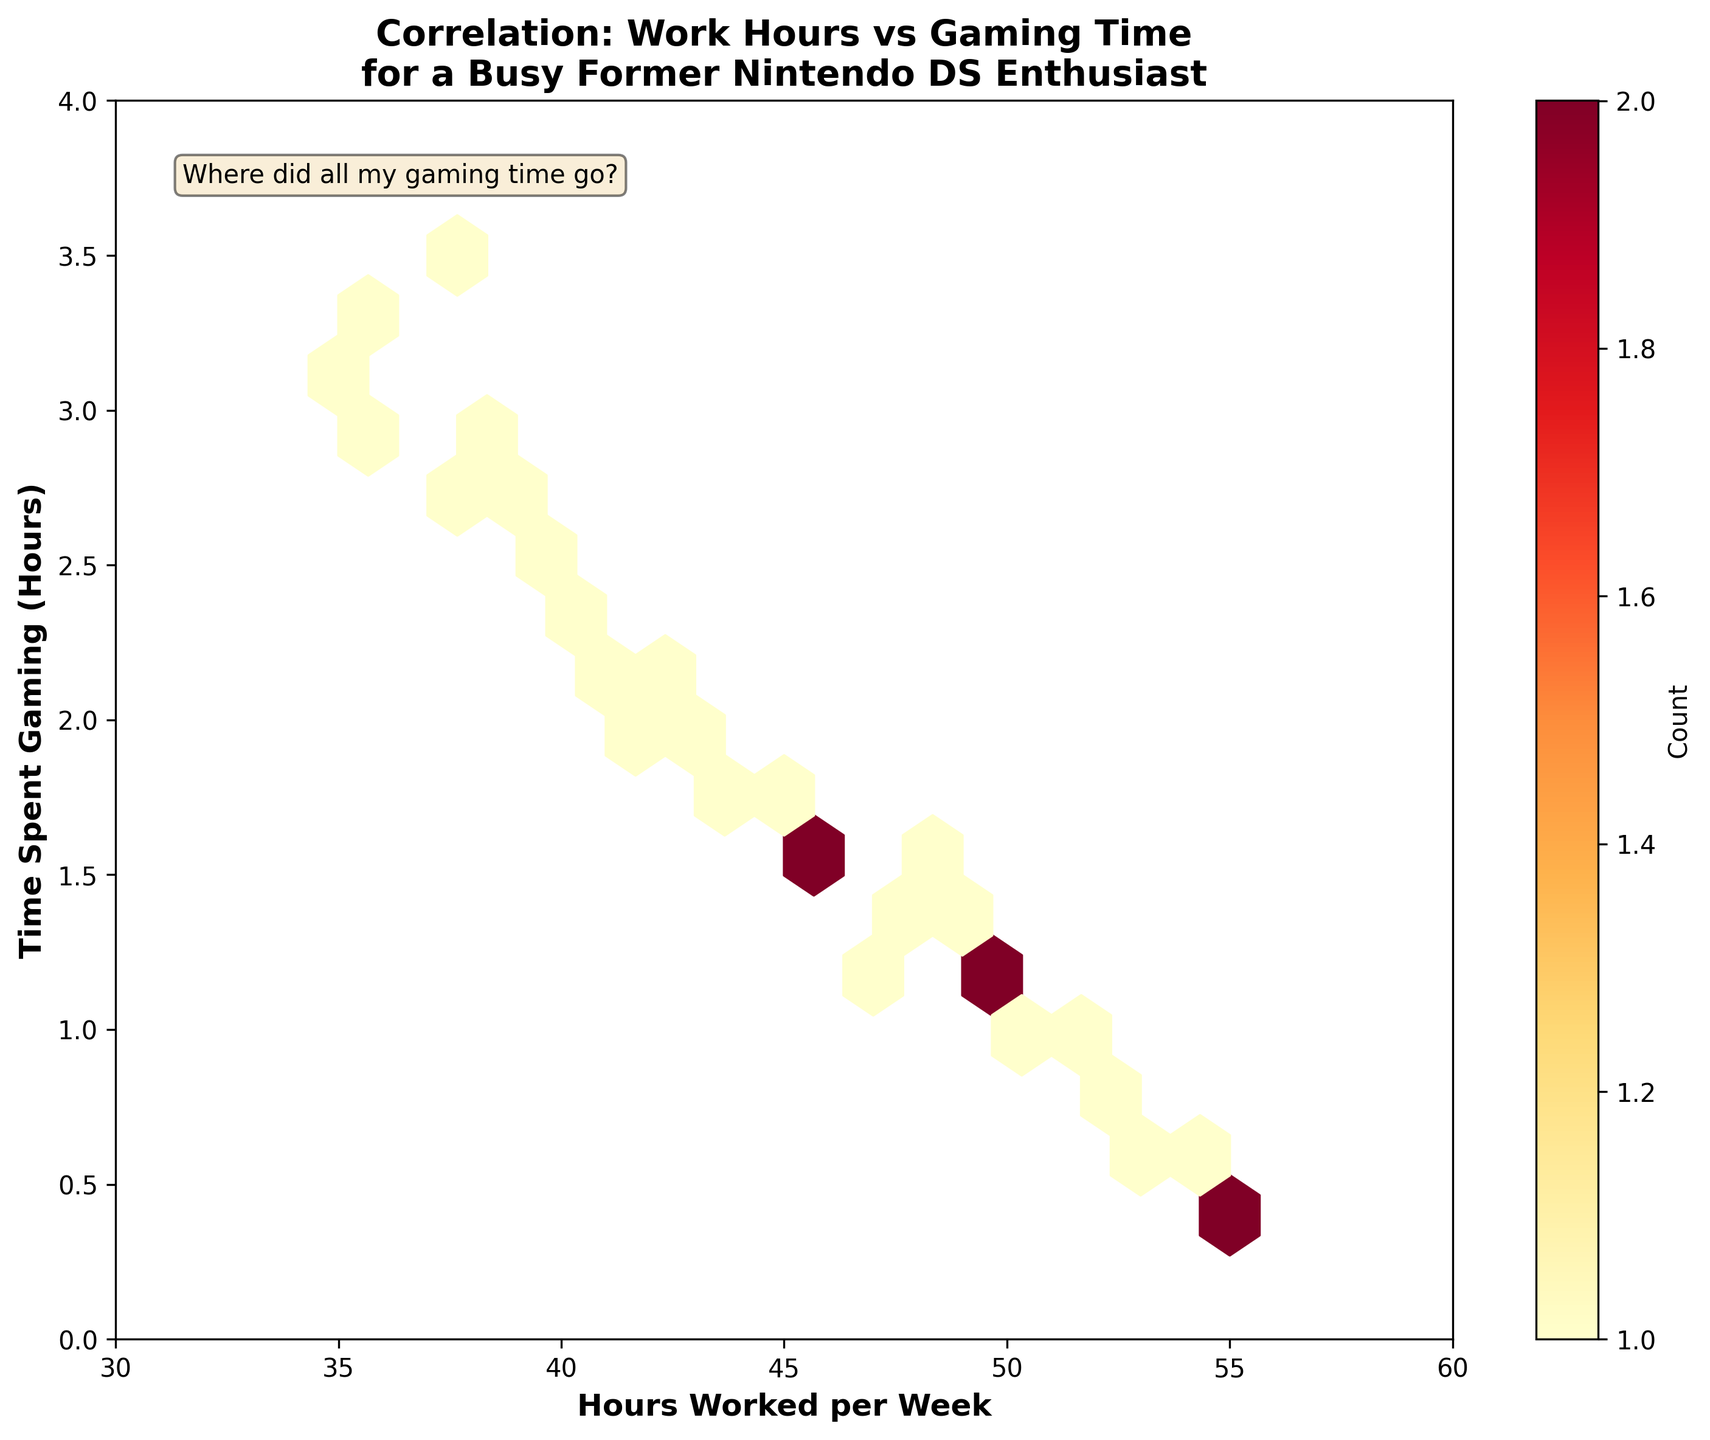What's the title of the plot? The title of the plot is often displayed prominently at the top of the figure. In this plot, it's displayed above the actual visual elements.
Answer: Correlation: Work Hours vs Gaming Time for a Busy Former Nintendo DS Enthusiast What does the x-axis represent in the plot? The x-axis label is given as "Hours Worked per Week," which indicates that this axis represents the number of hours worked per week.
Answer: Hours Worked per Week What is the range of time spent gaming on the y-axis? By looking at the y-axis, we can see it ranges from the minimum value at the bottom to the maximum value at the top. Here, it covers values from 0 to 4 hours.
Answer: 0 to 4 hours What does the color intensity in the hexagons indicate? The color intensity, indicated by a colorbar, typically shows density or the number of data points within each hexagon. In this plot, deeper colors represent higher counts of data points.
Answer: Number of data points in each hexagon What is the average time spent gaming for individuals who work 50 hours per week? To determine this, we find the hexagons that align with the 50-hour mark on the x-axis and calculate the average of these y-values. Here, we have 1.1 and 1.2 hours, so (1.1 + 1.2) / 2.
Answer: 1.15 hours How does the maximum gaming time change as work hours increase from 35 to 55 hours per week? As we inspect from 35 to 55 on the x-axis, the maximum y-values appear to decrease from around 3.2 hours at 35 hours to about 0.4-0.8 hours at 55 hours. This suggests a downward trend.
Answer: Decreases Are there any data points where the gaming time is completely zero? Each value on the y-axis represents time spent gaming in hours. The plot's hexagons do not extend below zero, indicating no data points are exactly at zero hours.
Answer: No Which work hours range contains the most people based on the densest hexagons? The hexagons' color intensity indicates the density of data points. The densest hexagons appear around the range of 40 to 45 hours of work per week.
Answer: 40 to 45 hours Is there a general trend between hours worked per week and time spent gaming observed in the plot? Observing the plot's overall shape, there's a visible negative slope where increased work hours correlate with decreased gaming time.
Answer: Negative correlation Based on the annotation, where did all the gaming time go? The annotation humorously hints at a change in gaming habits over time, suggesting that increased work hours contribute to the decrease in time available for gaming.
Answer: Increased work hours 